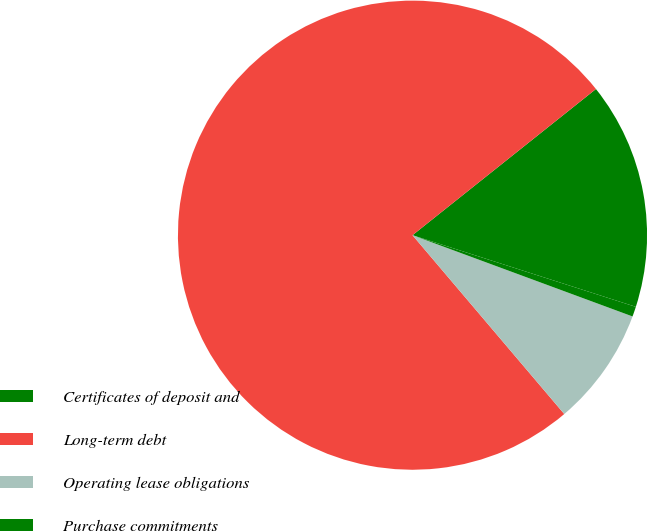Convert chart to OTSL. <chart><loc_0><loc_0><loc_500><loc_500><pie_chart><fcel>Certificates of deposit and<fcel>Long-term debt<fcel>Operating lease obligations<fcel>Purchase commitments<nl><fcel>15.65%<fcel>75.5%<fcel>8.17%<fcel>0.69%<nl></chart> 